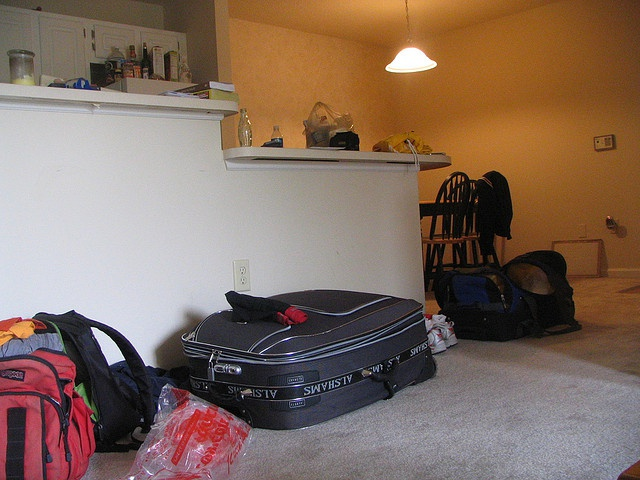Describe the objects in this image and their specific colors. I can see suitcase in darkgreen, black, gray, and darkgray tones, backpack in darkgreen, brown, and black tones, backpack in darkgreen, black, lavender, navy, and gray tones, suitcase in darkgreen, black, maroon, and gray tones, and chair in darkgreen, black, maroon, and brown tones in this image. 